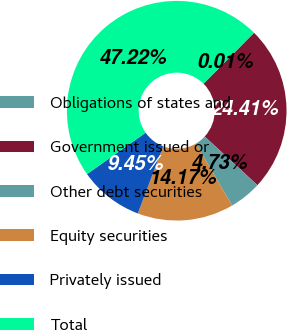Convert chart. <chart><loc_0><loc_0><loc_500><loc_500><pie_chart><fcel>Obligations of states and<fcel>Government issued or<fcel>Other debt securities<fcel>Equity securities<fcel>Privately issued<fcel>Total<nl><fcel>0.01%<fcel>24.41%<fcel>4.73%<fcel>14.17%<fcel>9.45%<fcel>47.21%<nl></chart> 